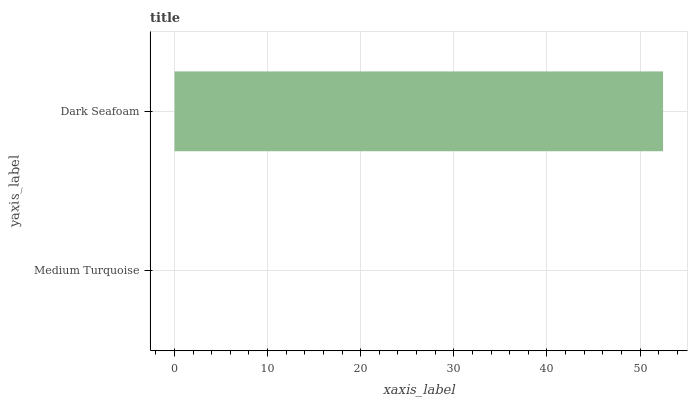Is Medium Turquoise the minimum?
Answer yes or no. Yes. Is Dark Seafoam the maximum?
Answer yes or no. Yes. Is Dark Seafoam the minimum?
Answer yes or no. No. Is Dark Seafoam greater than Medium Turquoise?
Answer yes or no. Yes. Is Medium Turquoise less than Dark Seafoam?
Answer yes or no. Yes. Is Medium Turquoise greater than Dark Seafoam?
Answer yes or no. No. Is Dark Seafoam less than Medium Turquoise?
Answer yes or no. No. Is Dark Seafoam the high median?
Answer yes or no. Yes. Is Medium Turquoise the low median?
Answer yes or no. Yes. Is Medium Turquoise the high median?
Answer yes or no. No. Is Dark Seafoam the low median?
Answer yes or no. No. 